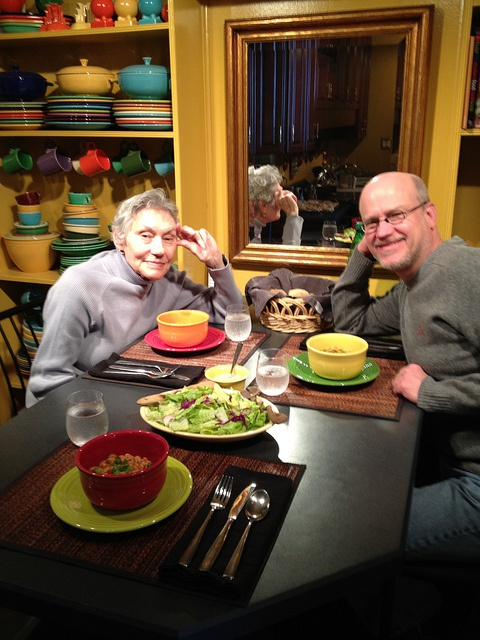Describe the objects in this image and their specific colors. I can see dining table in maroon, black, gray, and olive tones, people in maroon, black, gray, and salmon tones, people in maroon, lightgray, darkgray, gray, and lightpink tones, bowl in maroon and brown tones, and chair in maroon, black, and olive tones in this image. 